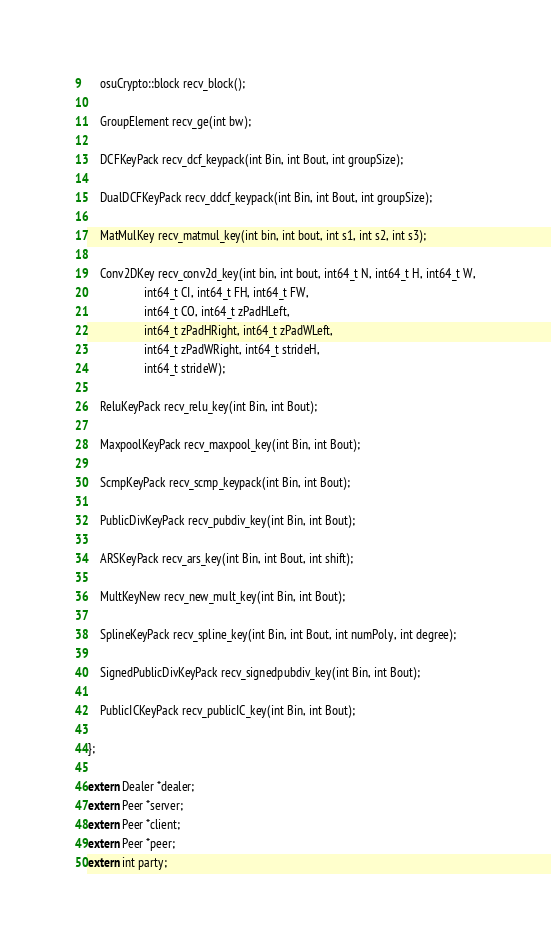<code> <loc_0><loc_0><loc_500><loc_500><_C_>    osuCrypto::block recv_block();

    GroupElement recv_ge(int bw);

    DCFKeyPack recv_dcf_keypack(int Bin, int Bout, int groupSize);

    DualDCFKeyPack recv_ddcf_keypack(int Bin, int Bout, int groupSize);

    MatMulKey recv_matmul_key(int bin, int bout, int s1, int s2, int s3);

    Conv2DKey recv_conv2d_key(int bin, int bout, int64_t N, int64_t H, int64_t W,
                   int64_t CI, int64_t FH, int64_t FW,
                   int64_t CO, int64_t zPadHLeft,
                   int64_t zPadHRight, int64_t zPadWLeft,
                   int64_t zPadWRight, int64_t strideH,
                   int64_t strideW);

    ReluKeyPack recv_relu_key(int Bin, int Bout);

    MaxpoolKeyPack recv_maxpool_key(int Bin, int Bout);

    ScmpKeyPack recv_scmp_keypack(int Bin, int Bout);

    PublicDivKeyPack recv_pubdiv_key(int Bin, int Bout);

    ARSKeyPack recv_ars_key(int Bin, int Bout, int shift);

    MultKeyNew recv_new_mult_key(int Bin, int Bout);

    SplineKeyPack recv_spline_key(int Bin, int Bout, int numPoly, int degree);

    SignedPublicDivKeyPack recv_signedpubdiv_key(int Bin, int Bout);

    PublicICKeyPack recv_publicIC_key(int Bin, int Bout);

};

extern Dealer *dealer;
extern Peer *server;
extern Peer *client;
extern Peer *peer;
extern int party;
</code> 